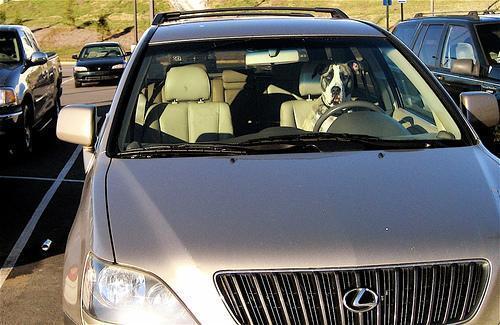How many trucks are there?
Give a very brief answer. 2. How many people running with a kite on the sand?
Give a very brief answer. 0. 